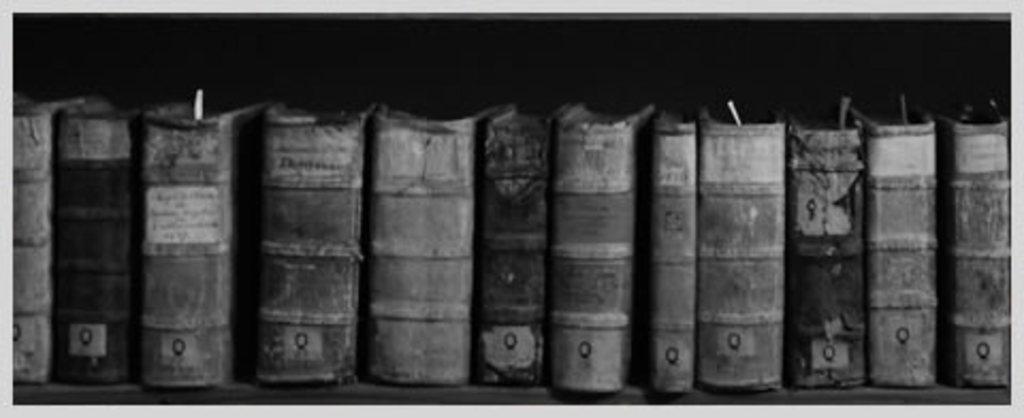What is the color scheme of the image? The image is black and white. What can be seen in the image? There are books arranged in rows in the image. What type of rock is visible in the image? There is no rock present in the image; it features books arranged in rows. What kind of apparel can be seen on the books in the image? Books do not wear apparel, so there is no clothing visible in the image. 